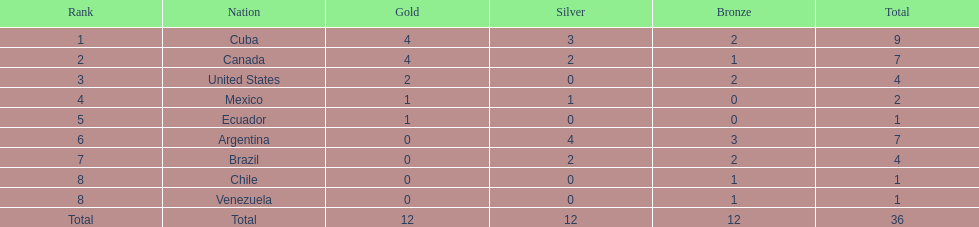Could you help me parse every detail presented in this table? {'header': ['Rank', 'Nation', 'Gold', 'Silver', 'Bronze', 'Total'], 'rows': [['1', 'Cuba', '4', '3', '2', '9'], ['2', 'Canada', '4', '2', '1', '7'], ['3', 'United States', '2', '0', '2', '4'], ['4', 'Mexico', '1', '1', '0', '2'], ['5', 'Ecuador', '1', '0', '0', '1'], ['6', 'Argentina', '0', '4', '3', '7'], ['7', 'Brazil', '0', '2', '2', '4'], ['8', 'Chile', '0', '0', '1', '1'], ['8', 'Venezuela', '0', '0', '1', '1'], ['Total', 'Total', '12', '12', '12', '36']]} What is mexico's ranking position? 4. 